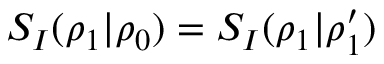<formula> <loc_0><loc_0><loc_500><loc_500>S _ { I } ( \rho _ { 1 } | \rho _ { 0 } ) = S _ { I } ( \rho _ { 1 } | \rho _ { 1 } ^ { \prime } )</formula> 